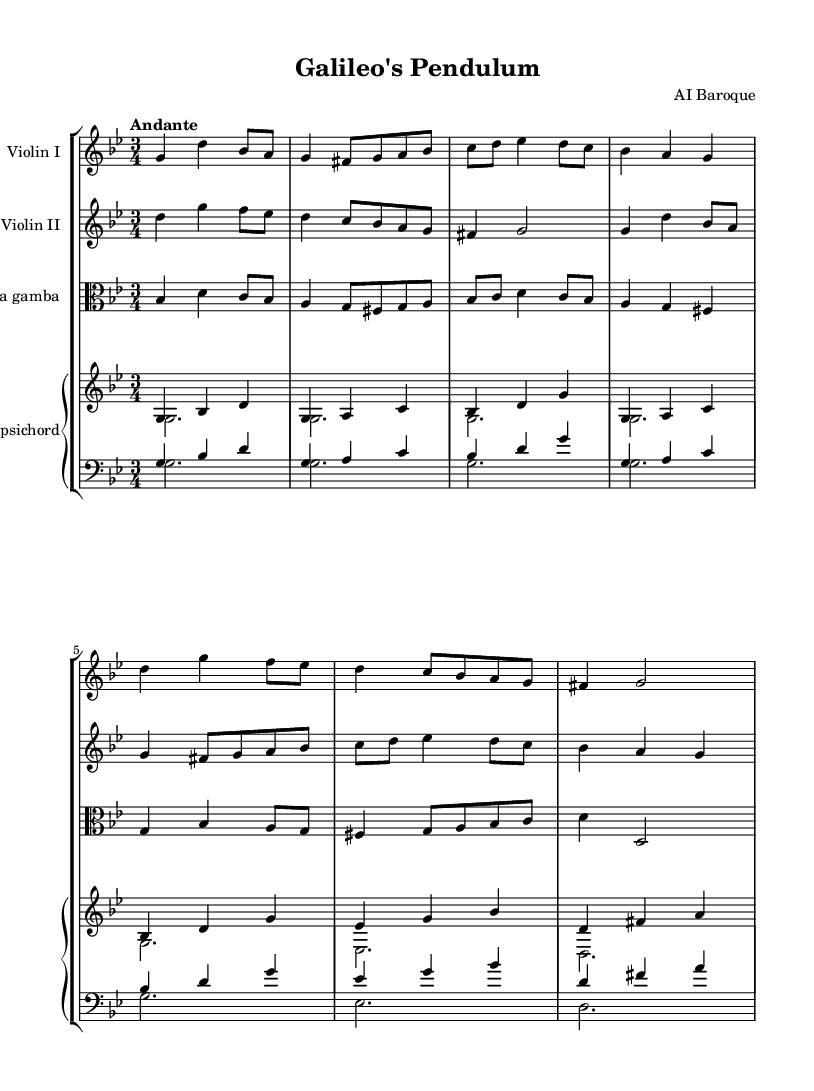What is the key signature of this music? The key signature is indicated at the beginning of the staff. Here, we can see two flats, which signify B flat and E flat. This corresponds to the key of G minor.
Answer: G minor What is the time signature of this music? The time signature is located at the beginning of the piece, represented by the numbers 3 and 4, indicating there are three beats in each measure and the quarter note gets one beat.
Answer: 3/4 What is the tempo marking of this piece? The tempo marking is found at the beginning as well, labeled as "Andante," which means a moderately slow pace.
Answer: Andante How many instrumental parts are there in total? By counting the distinct parts listed in the score, we find there are four parts: Violin I, Violin II, Viola da gamba, and Harpsichord. Therefore, the total is four.
Answer: 4 What is the highest note played by Violin I? To determine the highest note, we examine the notes in the Violin I part. The note represented as d' is the highest pitch used, which is an octave above middle C.
Answer: d' What is the function of the harpsichord in this music? The harpsichord is providing both harmonic support and a steady basso continuo, as indicated by its two distinct voices where one often doubles the melody. This is typical in Baroque chamber music.
Answer: Harmonic support What is a distinctive feature of the music regarding its structure? The piece showcases a contrapuntal texture, with multiple independent melodic lines being played simultaneously, transporting the listener through complex interactions typical of Baroque music.
Answer: Contrapuntal texture 